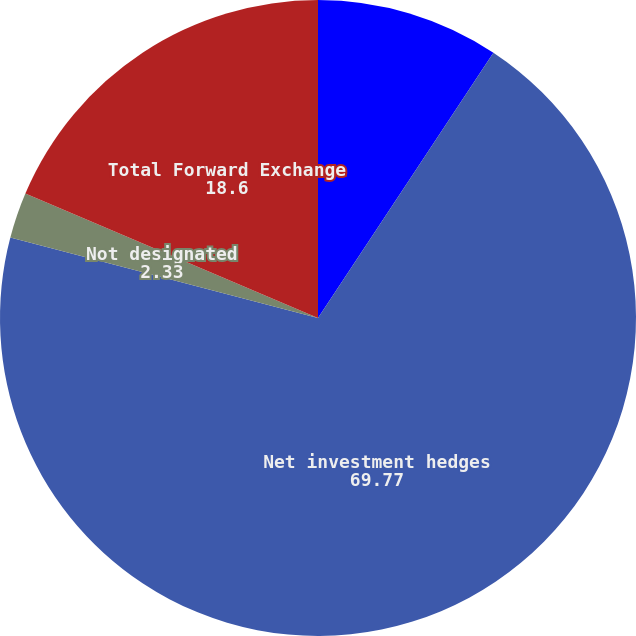Convert chart to OTSL. <chart><loc_0><loc_0><loc_500><loc_500><pie_chart><fcel>Cash flow hedges<fcel>Net investment hedges<fcel>Not designated<fcel>Total Forward Exchange<nl><fcel>9.3%<fcel>69.77%<fcel>2.33%<fcel>18.6%<nl></chart> 